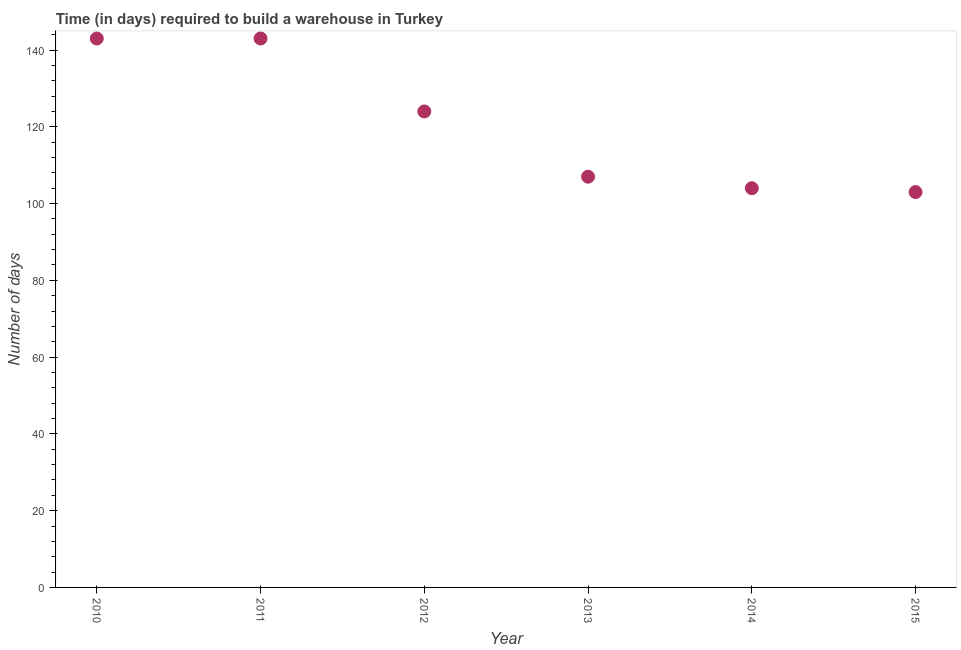What is the time required to build a warehouse in 2014?
Keep it short and to the point. 104. Across all years, what is the maximum time required to build a warehouse?
Provide a succinct answer. 143. Across all years, what is the minimum time required to build a warehouse?
Provide a short and direct response. 103. In which year was the time required to build a warehouse maximum?
Keep it short and to the point. 2010. In which year was the time required to build a warehouse minimum?
Provide a succinct answer. 2015. What is the sum of the time required to build a warehouse?
Ensure brevity in your answer.  724. What is the difference between the time required to build a warehouse in 2012 and 2013?
Give a very brief answer. 17. What is the average time required to build a warehouse per year?
Ensure brevity in your answer.  120.67. What is the median time required to build a warehouse?
Give a very brief answer. 115.5. Do a majority of the years between 2012 and 2010 (inclusive) have time required to build a warehouse greater than 112 days?
Offer a very short reply. No. What is the ratio of the time required to build a warehouse in 2013 to that in 2015?
Keep it short and to the point. 1.04. Is the time required to build a warehouse in 2014 less than that in 2015?
Your response must be concise. No. Is the difference between the time required to build a warehouse in 2010 and 2012 greater than the difference between any two years?
Keep it short and to the point. No. What is the difference between the highest and the second highest time required to build a warehouse?
Ensure brevity in your answer.  0. What is the difference between the highest and the lowest time required to build a warehouse?
Provide a succinct answer. 40. How many dotlines are there?
Your response must be concise. 1. How many years are there in the graph?
Provide a short and direct response. 6. Does the graph contain any zero values?
Provide a short and direct response. No. What is the title of the graph?
Give a very brief answer. Time (in days) required to build a warehouse in Turkey. What is the label or title of the X-axis?
Give a very brief answer. Year. What is the label or title of the Y-axis?
Your answer should be very brief. Number of days. What is the Number of days in 2010?
Offer a very short reply. 143. What is the Number of days in 2011?
Your response must be concise. 143. What is the Number of days in 2012?
Give a very brief answer. 124. What is the Number of days in 2013?
Offer a very short reply. 107. What is the Number of days in 2014?
Offer a terse response. 104. What is the Number of days in 2015?
Ensure brevity in your answer.  103. What is the difference between the Number of days in 2011 and 2013?
Make the answer very short. 36. What is the difference between the Number of days in 2012 and 2015?
Offer a terse response. 21. What is the difference between the Number of days in 2013 and 2015?
Provide a short and direct response. 4. What is the ratio of the Number of days in 2010 to that in 2011?
Give a very brief answer. 1. What is the ratio of the Number of days in 2010 to that in 2012?
Your answer should be very brief. 1.15. What is the ratio of the Number of days in 2010 to that in 2013?
Your answer should be compact. 1.34. What is the ratio of the Number of days in 2010 to that in 2014?
Provide a succinct answer. 1.38. What is the ratio of the Number of days in 2010 to that in 2015?
Keep it short and to the point. 1.39. What is the ratio of the Number of days in 2011 to that in 2012?
Make the answer very short. 1.15. What is the ratio of the Number of days in 2011 to that in 2013?
Keep it short and to the point. 1.34. What is the ratio of the Number of days in 2011 to that in 2014?
Your response must be concise. 1.38. What is the ratio of the Number of days in 2011 to that in 2015?
Offer a terse response. 1.39. What is the ratio of the Number of days in 2012 to that in 2013?
Your response must be concise. 1.16. What is the ratio of the Number of days in 2012 to that in 2014?
Make the answer very short. 1.19. What is the ratio of the Number of days in 2012 to that in 2015?
Keep it short and to the point. 1.2. What is the ratio of the Number of days in 2013 to that in 2014?
Provide a short and direct response. 1.03. What is the ratio of the Number of days in 2013 to that in 2015?
Ensure brevity in your answer.  1.04. 